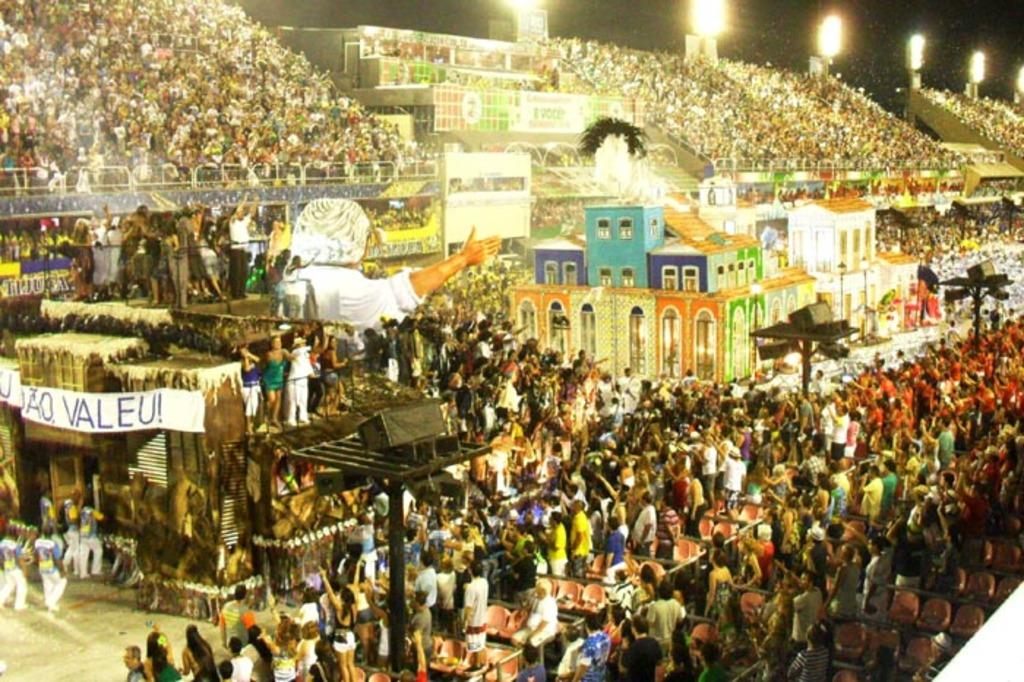What can be seen in the image in terms of people? There are groups of people in the image. What type of structure is present in the image? There is a building in the image. Are there any lighting features in the image? Yes, there are lights in the image. What architectural element is visible in the image? There are stairs in the image. Can you see a giraffe walking up the stairs in the image? No, there is no giraffe present in the image. 